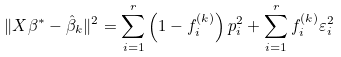<formula> <loc_0><loc_0><loc_500><loc_500>\| X \beta ^ { * } - \hat { \beta } _ { k } \| ^ { 2 } = \sum _ { i = 1 } ^ { r } \left ( 1 - f _ { i } ^ { ( k ) } \right ) p _ { i } ^ { 2 } + \sum _ { i = 1 } ^ { r } f _ { i } ^ { ( k ) } \varepsilon _ { i } ^ { 2 }</formula> 